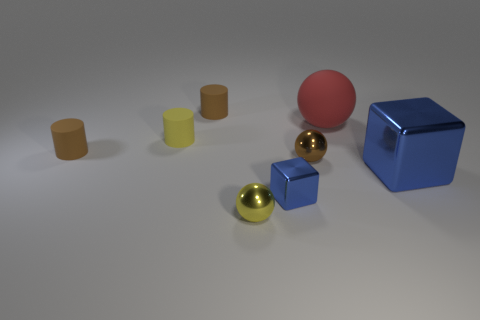Add 1 rubber cylinders. How many objects exist? 9 Subtract all cylinders. How many objects are left? 5 Subtract 0 gray balls. How many objects are left? 8 Subtract all tiny brown cylinders. Subtract all tiny metal balls. How many objects are left? 4 Add 7 large rubber balls. How many large rubber balls are left? 8 Add 2 large blue metallic things. How many large blue metallic things exist? 3 